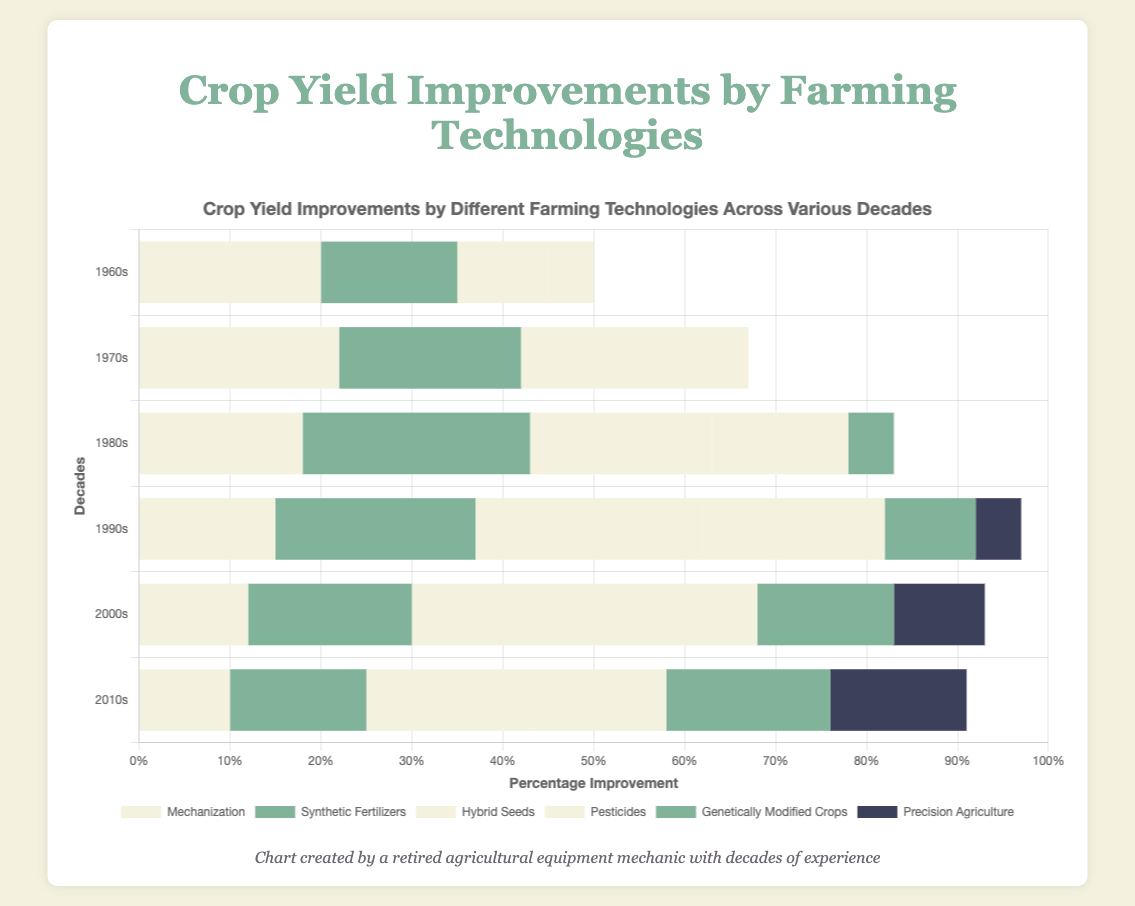What technology had the highest percentage improvement in the 1970s? To find the technology with the highest percentage improvement in the 1970s, locate the technology with the tallest bar portion for that decade. Hybrid Seeds improved by 15%, Synthetic Fertilizers by 20%, Mechanization by 22%, Pesticides by 10%, Genetically Modified Crops by 0%, and Precision Agriculture by 0%. Mechanization has the highest percentage at 22%.
Answer: Mechanization Which decade saw the greatest percentage improvement from Synthetic Fertilizers? Examine the stacked bar slices representing Synthetic Fertilizers across all decades. The bars are 15% in the 1960s, 20% in the 1970s, 25% in the 1980s, 22% in the 1990s, 18% in the 2000s, and 15% in the 2010s. The highest value is in the 1980s with 25%.
Answer: 1980s How does the contribution of Hybrid Seeds in the 2000s compare to Mechanization in the same decade? For this comparison, check the heights of the segments in the 2000s for both technologies. Hybrid Seeds contributed 20%, while Mechanization contributed 12%. Hybrid Seeds exceeded Mechanization by 8%.
Answer: Hybrid Seeds contributed 8% more What is the total yield improvement from all technologies in the 1990s? To find the total yield improvement, sum all segments for the 1990s. Mechanization: 15%, Synthetic Fertilizers: 22%, Hybrid Seeds: 25%, Pesticides: 20%, Genetically Modified Crops: 10%, Precision Agriculture: 5%. Total: 15 + 22 + 25 + 20 + 10 + 5 = 97%.
Answer: 97% Which technology had a consistent increase in its contribution every decade from the 1960s to the 2010s? Identify the technology with values increasing without dips through all decades. Pesticides grew from 5% (1960s), 10% (1970s), 15% (1980s), 20% (1990s), 18% (2000s), and 15% (2010s), showing a decline. Genetically Modified Crops and Precision Agriculture show consistent growth starting later decades. Genetically Modified Crops grew from 0% (1960s and 1970s), 5% (1980s), 10% (1990s), 15% (2000s), and 18% (2010s).
Answer: Genetically Modified Crops How much did the contribution of Precision Agriculture grow from the 1990s to the 2010s? Look at the bars representing Precision Agriculture in the 1990s and 2010s. It grew from 5% in the 1990s to 15% in the 2010s, so the growth is 15% - 5% = 10%.
Answer: 10% Which technology's contribution decreased the most from the 1960s to the 2010s? Compare the values of each technology from the 1960s and the 2010s. Mechanization: 20% to 10% (decrease of 10%), Synthetic Fertilizers: 15% to 15% (no change), Hybrid Seeds: 10% to 18% (increase), Pesticides: 5% to 15% (increase), Genetically Modified Crops: 0% to 18% (increase), Precision Agriculture: 0% to 15% (increase). Mechanization decreased the most, by 10%.
Answer: Mechanization Calculate the average percentage improvement contributed by Hybrid Seeds across all decades. To find the average, sum the percentages for Hybrid Seeds across all decades and divide by the number of decades (6). The values are: 10 (1960s), 15 (1970s), 20 (1980s), 25 (1990s), 20 (2000s), 18 (2010s). Total: 10+15+20+25+20+18 = 108. Average: 108/6 = 18%.
Answer: 18% In which decade did Mechanization experience the greatest percentage decrease compared to the previous decade? Compare Mechanization values across decades. The decreases are: 1960s (20%) to 1970s (22%) (+2%), 1970s (22%) to 1980s (18%) (-4%), 1980s (18%) to 1990s (15%) (-3%), 1990s (15%) to 2000s (12%) (-3%), 2000s (12%) to 2010s (10%) (-2%). The biggest drop is from the 1970s to the 1980s (-4%).
Answer: 1980s 